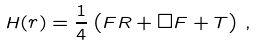Convert formula to latex. <formula><loc_0><loc_0><loc_500><loc_500>H ( r ) = \frac { 1 } { 4 } \left ( F R + \Box F + T \right ) \, ,</formula> 